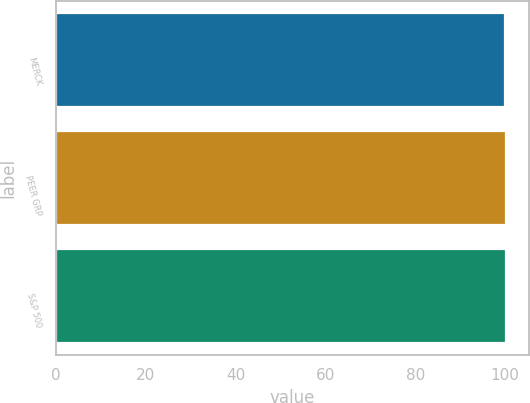Convert chart. <chart><loc_0><loc_0><loc_500><loc_500><bar_chart><fcel>MERCK<fcel>PEER GRP<fcel>S&P 500<nl><fcel>100<fcel>100.1<fcel>100.2<nl></chart> 